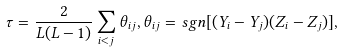<formula> <loc_0><loc_0><loc_500><loc_500>\tau = \frac { 2 } { L ( L - 1 ) } \sum _ { i < j } \theta _ { i j } , \theta _ { i j } = s g n [ ( Y _ { i } - Y _ { j } ) ( Z _ { i } - Z _ { j } ) ] ,</formula> 